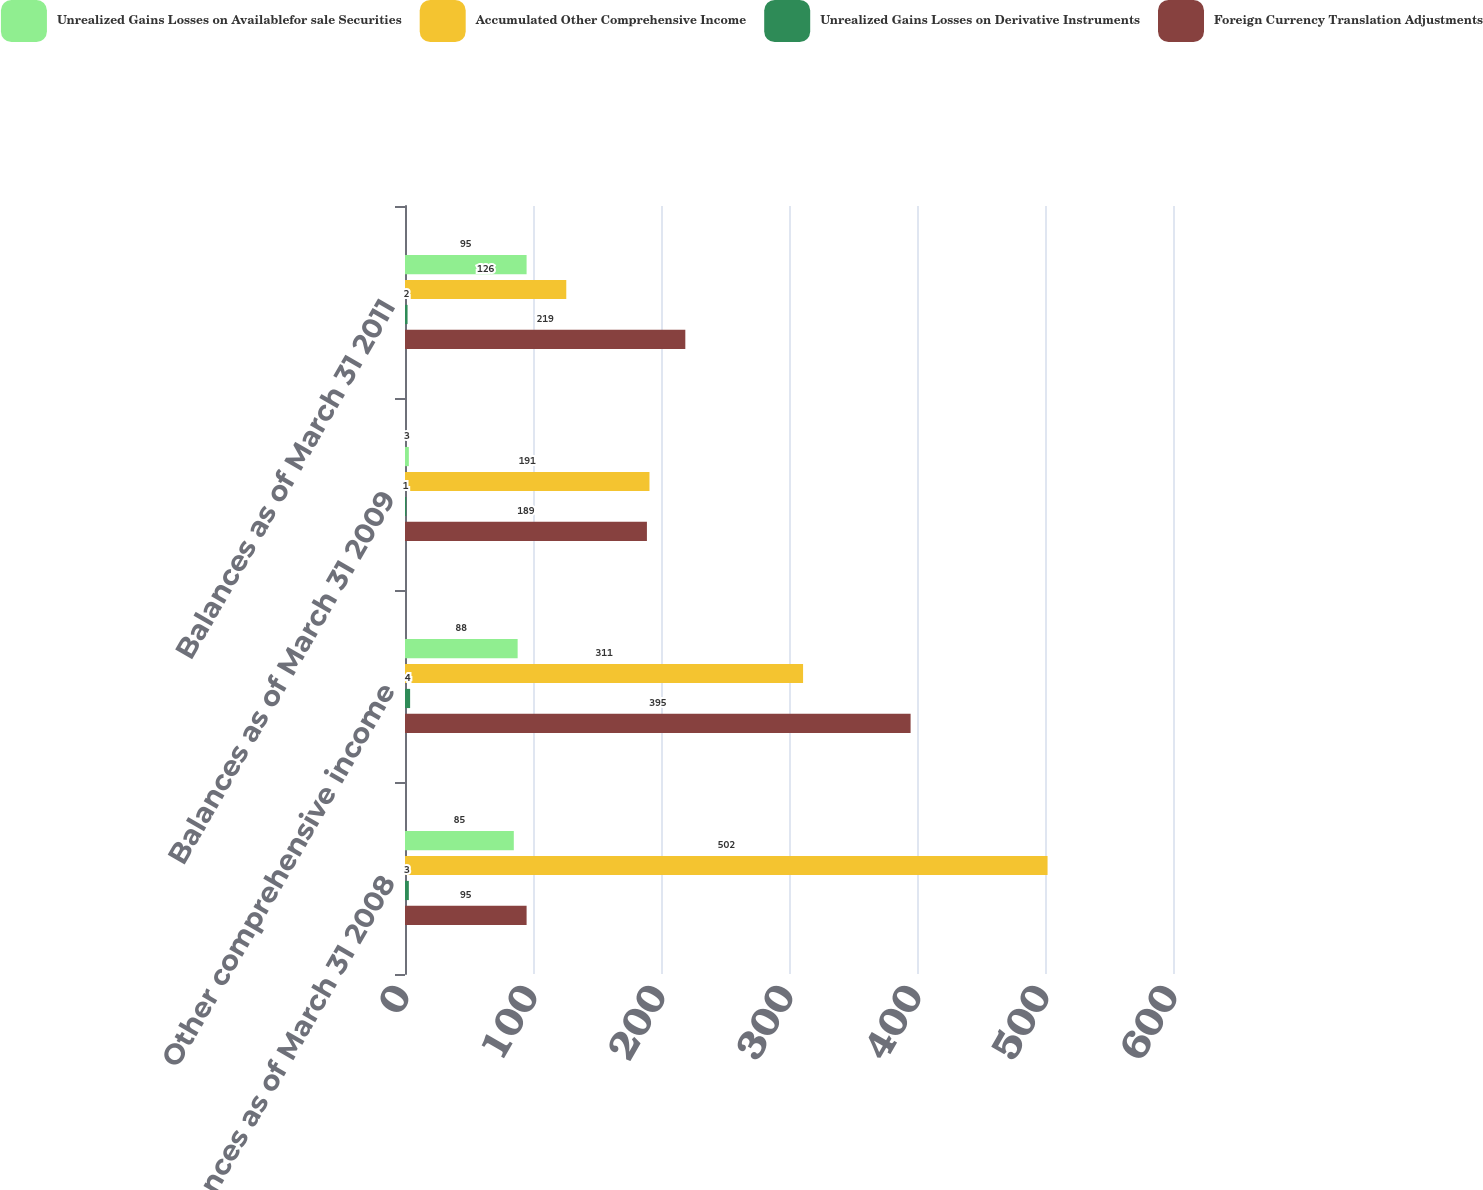Convert chart to OTSL. <chart><loc_0><loc_0><loc_500><loc_500><stacked_bar_chart><ecel><fcel>Balances as of March 31 2008<fcel>Other comprehensive income<fcel>Balances as of March 31 2009<fcel>Balances as of March 31 2011<nl><fcel>Unrealized Gains Losses on Availablefor sale Securities<fcel>85<fcel>88<fcel>3<fcel>95<nl><fcel>Accumulated Other Comprehensive Income<fcel>502<fcel>311<fcel>191<fcel>126<nl><fcel>Unrealized Gains Losses on Derivative Instruments<fcel>3<fcel>4<fcel>1<fcel>2<nl><fcel>Foreign Currency Translation Adjustments<fcel>95<fcel>395<fcel>189<fcel>219<nl></chart> 